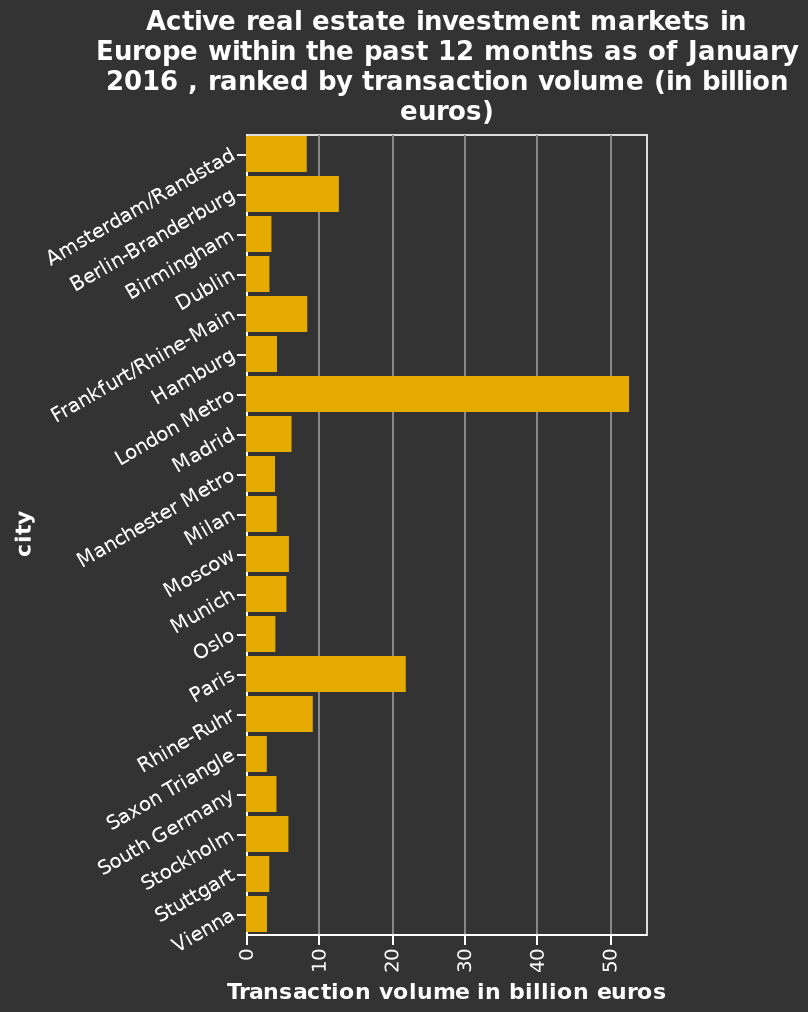<image>
How many cities are labeled on the y-axis of the bar diagram? The y-axis of the bar diagram is labeled with cities, and there are multiple cities labeled on it. 